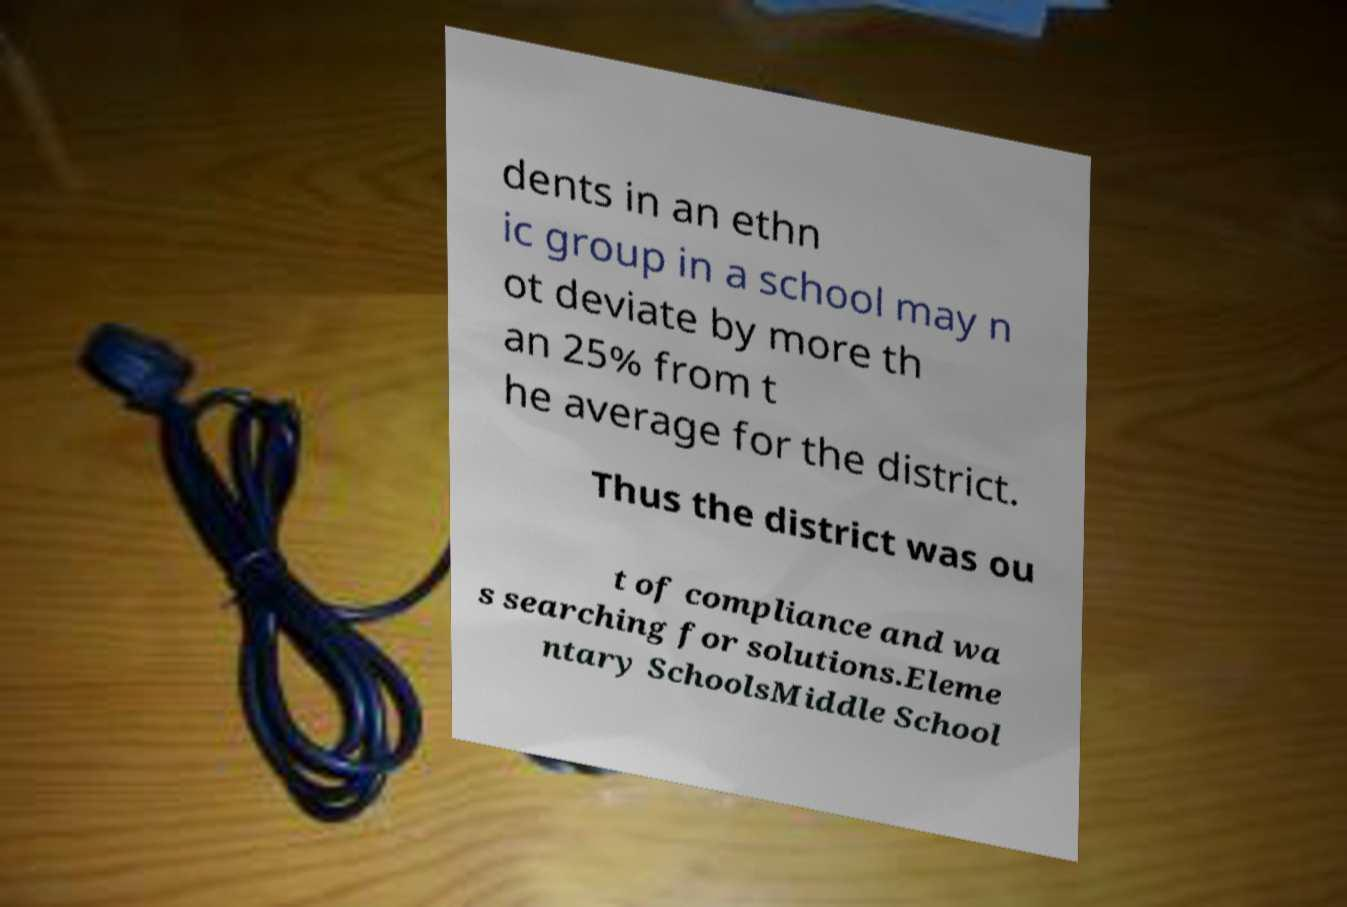Please read and relay the text visible in this image. What does it say? dents in an ethn ic group in a school may n ot deviate by more th an 25% from t he average for the district. Thus the district was ou t of compliance and wa s searching for solutions.Eleme ntary SchoolsMiddle School 